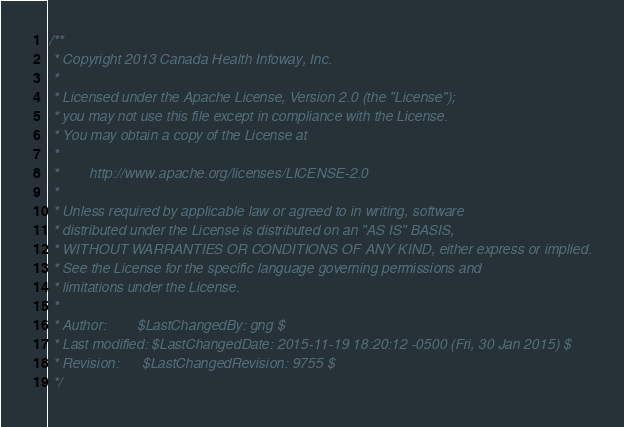<code> <loc_0><loc_0><loc_500><loc_500><_C#_>/**
 * Copyright 2013 Canada Health Infoway, Inc.
 *
 * Licensed under the Apache License, Version 2.0 (the "License");
 * you may not use this file except in compliance with the License.
 * You may obtain a copy of the License at
 *
 *        http://www.apache.org/licenses/LICENSE-2.0
 *
 * Unless required by applicable law or agreed to in writing, software
 * distributed under the License is distributed on an "AS IS" BASIS,
 * WITHOUT WARRANTIES OR CONDITIONS OF ANY KIND, either express or implied.
 * See the License for the specific language governing permissions and
 * limitations under the License.
 *
 * Author:        $LastChangedBy: gng $
 * Last modified: $LastChangedDate: 2015-11-19 18:20:12 -0500 (Fri, 30 Jan 2015) $
 * Revision:      $LastChangedRevision: 9755 $
 */
</code> 